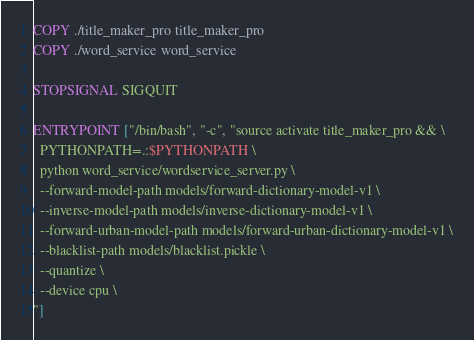Convert code to text. <code><loc_0><loc_0><loc_500><loc_500><_Dockerfile_>COPY ./title_maker_pro title_maker_pro
COPY ./word_service word_service

STOPSIGNAL SIGQUIT

ENTRYPOINT ["/bin/bash", "-c", "source activate title_maker_pro && \
  PYTHONPATH=.:$PYTHONPATH \
  python word_service/wordservice_server.py \
  --forward-model-path models/forward-dictionary-model-v1 \
  --inverse-model-path models/inverse-dictionary-model-v1 \
  --forward-urban-model-path models/forward-urban-dictionary-model-v1 \
  --blacklist-path models/blacklist.pickle \
  --quantize \
  --device cpu \
"]
</code> 